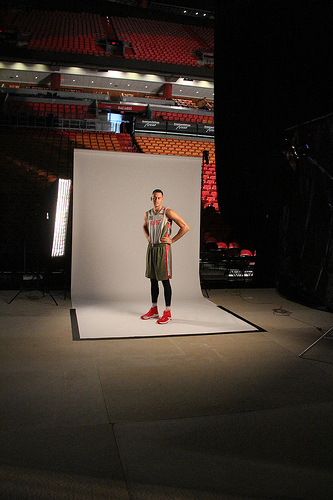<image>
Can you confirm if the player is in front of the board? Yes. The player is positioned in front of the board, appearing closer to the camera viewpoint. 